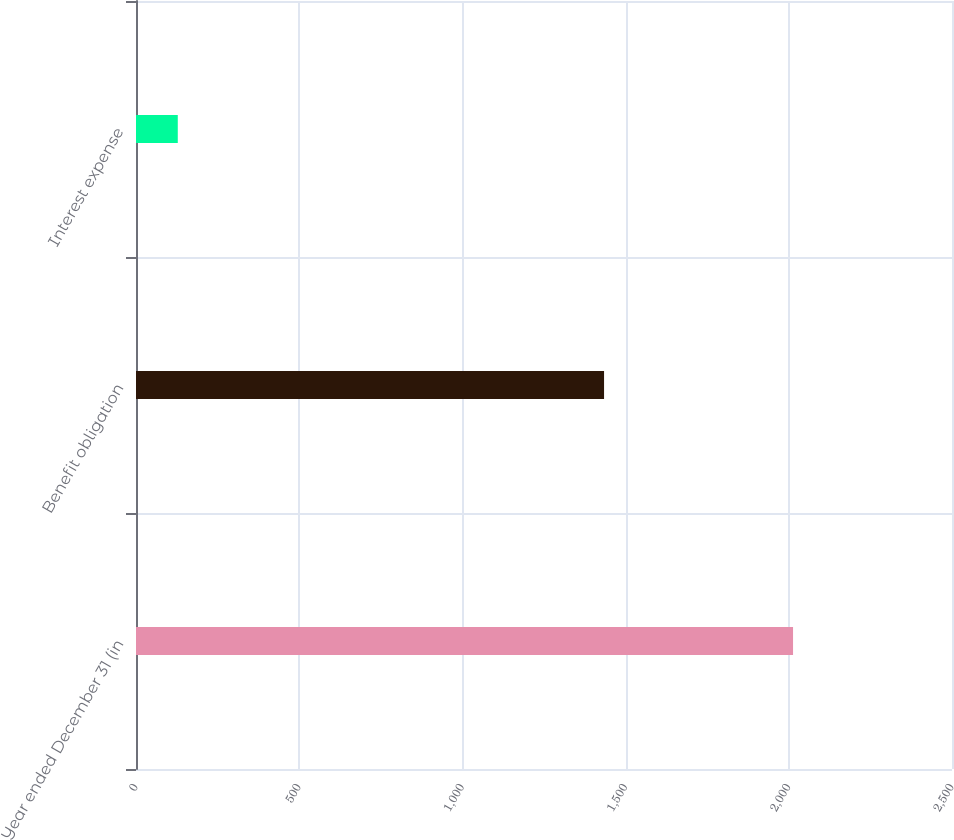<chart> <loc_0><loc_0><loc_500><loc_500><bar_chart><fcel>Year ended December 31 (in<fcel>Benefit obligation<fcel>Interest expense<nl><fcel>2013<fcel>1434<fcel>128<nl></chart> 